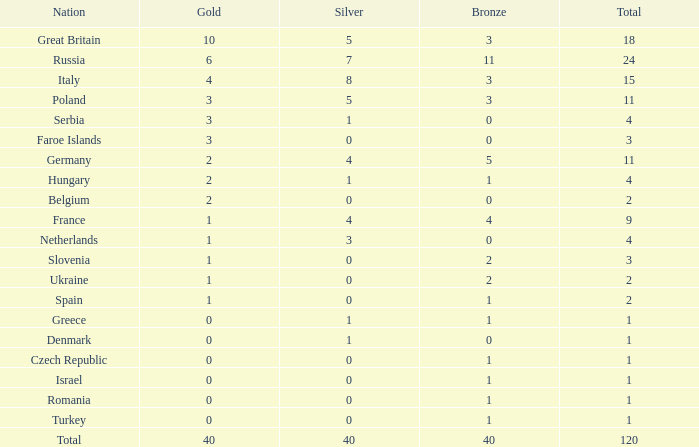What is the average Gold entry for the Netherlands that also has a Bronze entry that is greater than 0? None. 